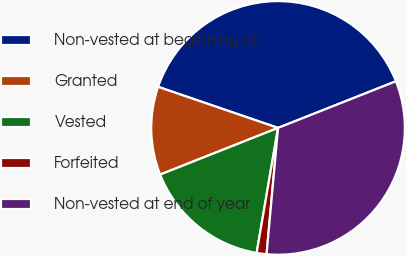<chart> <loc_0><loc_0><loc_500><loc_500><pie_chart><fcel>Non-vested at beginning of<fcel>Granted<fcel>Vested<fcel>Forfeited<fcel>Non-vested at end of year<nl><fcel>38.75%<fcel>11.25%<fcel>16.3%<fcel>1.26%<fcel>32.44%<nl></chart> 